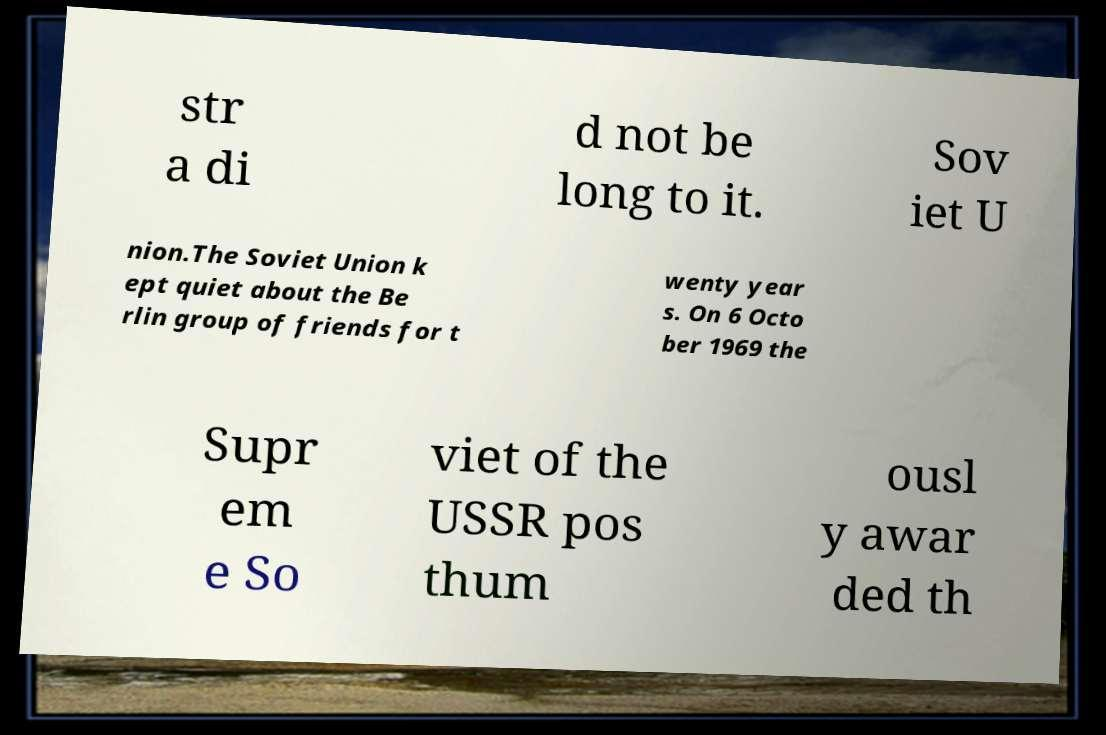Please read and relay the text visible in this image. What does it say? str a di d not be long to it. Sov iet U nion.The Soviet Union k ept quiet about the Be rlin group of friends for t wenty year s. On 6 Octo ber 1969 the Supr em e So viet of the USSR pos thum ousl y awar ded th 